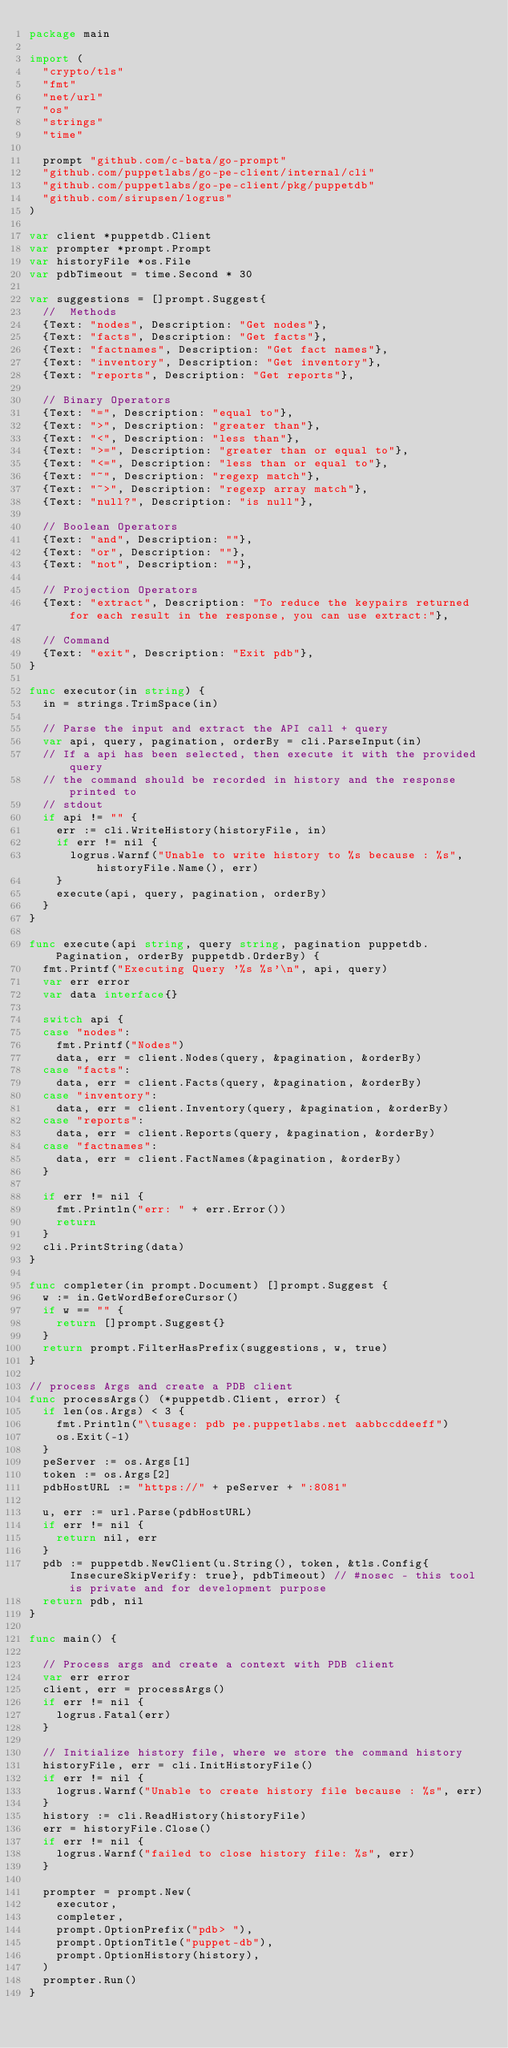Convert code to text. <code><loc_0><loc_0><loc_500><loc_500><_Go_>package main

import (
	"crypto/tls"
	"fmt"
	"net/url"
	"os"
	"strings"
	"time"

	prompt "github.com/c-bata/go-prompt"
	"github.com/puppetlabs/go-pe-client/internal/cli"
	"github.com/puppetlabs/go-pe-client/pkg/puppetdb"
	"github.com/sirupsen/logrus"
)

var client *puppetdb.Client
var prompter *prompt.Prompt
var historyFile *os.File
var pdbTimeout = time.Second * 30

var suggestions = []prompt.Suggest{
	//  Methods
	{Text: "nodes", Description: "Get nodes"},
	{Text: "facts", Description: "Get facts"},
	{Text: "factnames", Description: "Get fact names"},
	{Text: "inventory", Description: "Get inventory"},
	{Text: "reports", Description: "Get reports"},

	// Binary Operators
	{Text: "=", Description: "equal to"},
	{Text: ">", Description: "greater than"},
	{Text: "<", Description: "less than"},
	{Text: ">=", Description: "greater than or equal to"},
	{Text: "<=", Description: "less than or equal to"},
	{Text: "~", Description: "regexp match"},
	{Text: "~>", Description: "regexp array match"},
	{Text: "null?", Description: "is null"},

	// Boolean Operators
	{Text: "and", Description: ""},
	{Text: "or", Description: ""},
	{Text: "not", Description: ""},

	// Projection Operators
	{Text: "extract", Description: "To reduce the keypairs returned for each result in the response, you can use extract:"},

	// Command
	{Text: "exit", Description: "Exit pdb"},
}

func executor(in string) {
	in = strings.TrimSpace(in)

	// Parse the input and extract the API call + query
	var api, query, pagination, orderBy = cli.ParseInput(in)
	// If a api has been selected, then execute it with the provided query
	// the command should be recorded in history and the response printed to
	// stdout
	if api != "" {
		err := cli.WriteHistory(historyFile, in)
		if err != nil {
			logrus.Warnf("Unable to write history to %s because : %s", historyFile.Name(), err)
		}
		execute(api, query, pagination, orderBy)
	}
}

func execute(api string, query string, pagination puppetdb.Pagination, orderBy puppetdb.OrderBy) {
	fmt.Printf("Executing Query '%s %s'\n", api, query)
	var err error
	var data interface{}

	switch api {
	case "nodes":
		fmt.Printf("Nodes")
		data, err = client.Nodes(query, &pagination, &orderBy)
	case "facts":
		data, err = client.Facts(query, &pagination, &orderBy)
	case "inventory":
		data, err = client.Inventory(query, &pagination, &orderBy)
	case "reports":
		data, err = client.Reports(query, &pagination, &orderBy)
	case "factnames":
		data, err = client.FactNames(&pagination, &orderBy)
	}

	if err != nil {
		fmt.Println("err: " + err.Error())
		return
	}
	cli.PrintString(data)
}

func completer(in prompt.Document) []prompt.Suggest {
	w := in.GetWordBeforeCursor()
	if w == "" {
		return []prompt.Suggest{}
	}
	return prompt.FilterHasPrefix(suggestions, w, true)
}

// process Args and create a PDB client
func processArgs() (*puppetdb.Client, error) {
	if len(os.Args) < 3 {
		fmt.Println("\tusage: pdb pe.puppetlabs.net aabbccddeeff")
		os.Exit(-1)
	}
	peServer := os.Args[1]
	token := os.Args[2]
	pdbHostURL := "https://" + peServer + ":8081"

	u, err := url.Parse(pdbHostURL)
	if err != nil {
		return nil, err
	}
	pdb := puppetdb.NewClient(u.String(), token, &tls.Config{InsecureSkipVerify: true}, pdbTimeout) // #nosec - this tool is private and for development purpose
	return pdb, nil
}

func main() {

	// Process args and create a context with PDB client
	var err error
	client, err = processArgs()
	if err != nil {
		logrus.Fatal(err)
	}

	// Initialize history file, where we store the command history
	historyFile, err = cli.InitHistoryFile()
	if err != nil {
		logrus.Warnf("Unable to create history file because : %s", err)
	}
	history := cli.ReadHistory(historyFile)
	err = historyFile.Close()
	if err != nil {
		logrus.Warnf("failed to close history file: %s", err)
	}

	prompter = prompt.New(
		executor,
		completer,
		prompt.OptionPrefix("pdb> "),
		prompt.OptionTitle("puppet-db"),
		prompt.OptionHistory(history),
	)
	prompter.Run()
}
</code> 